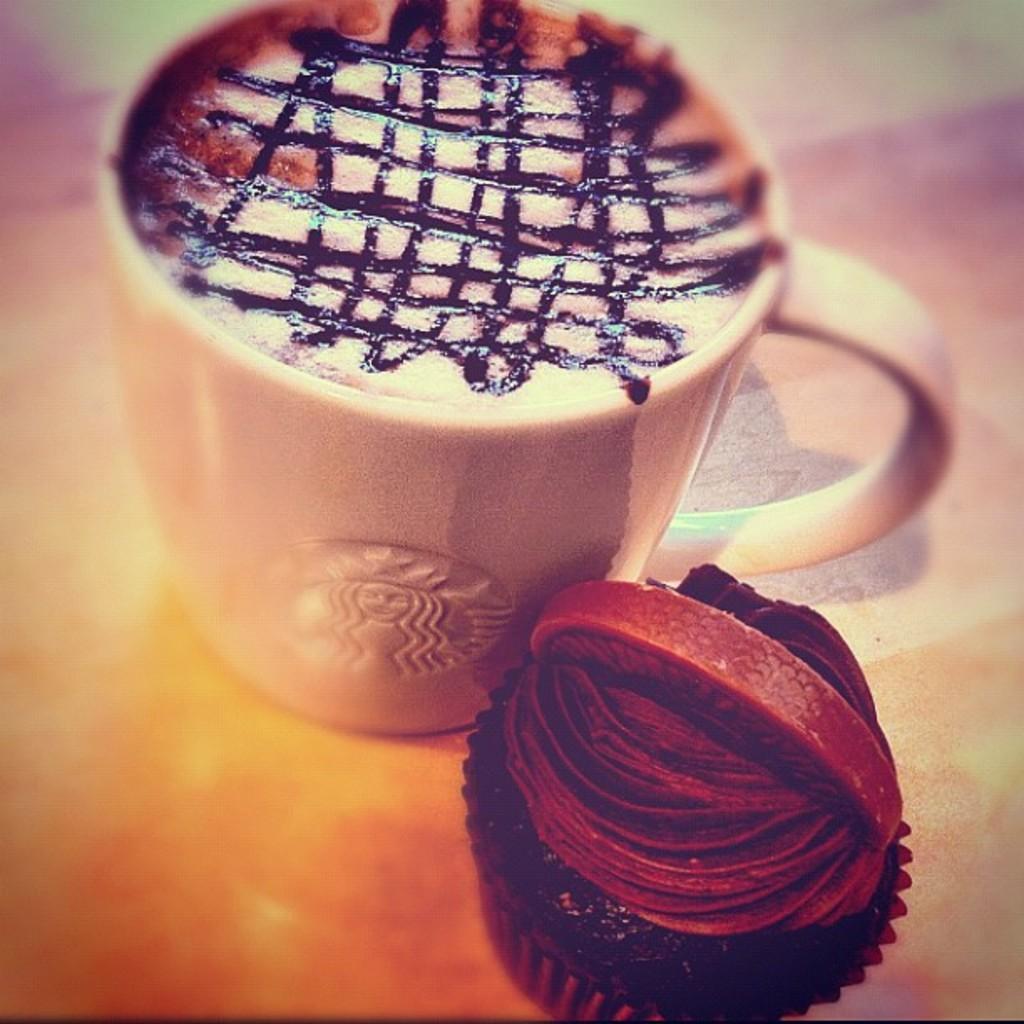Could you give a brief overview of what you see in this image? In this image, we can see a cup with coffee and muffin are placed on the surface. The borders of the image, we can see blur view. 